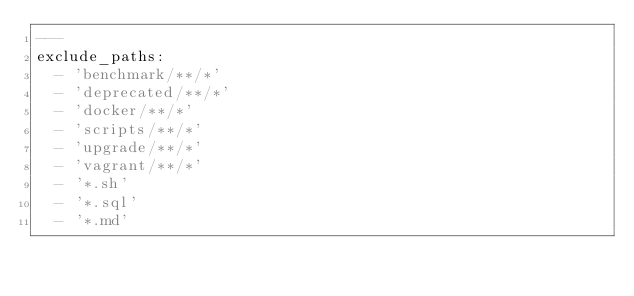Convert code to text. <code><loc_0><loc_0><loc_500><loc_500><_YAML_>---
exclude_paths:
  - 'benchmark/**/*'
  - 'deprecated/**/*'
  - 'docker/**/*'
  - 'scripts/**/*'
  - 'upgrade/**/*'
  - 'vagrant/**/*'
  - '*.sh'
  - '*.sql'
  - '*.md'
</code> 